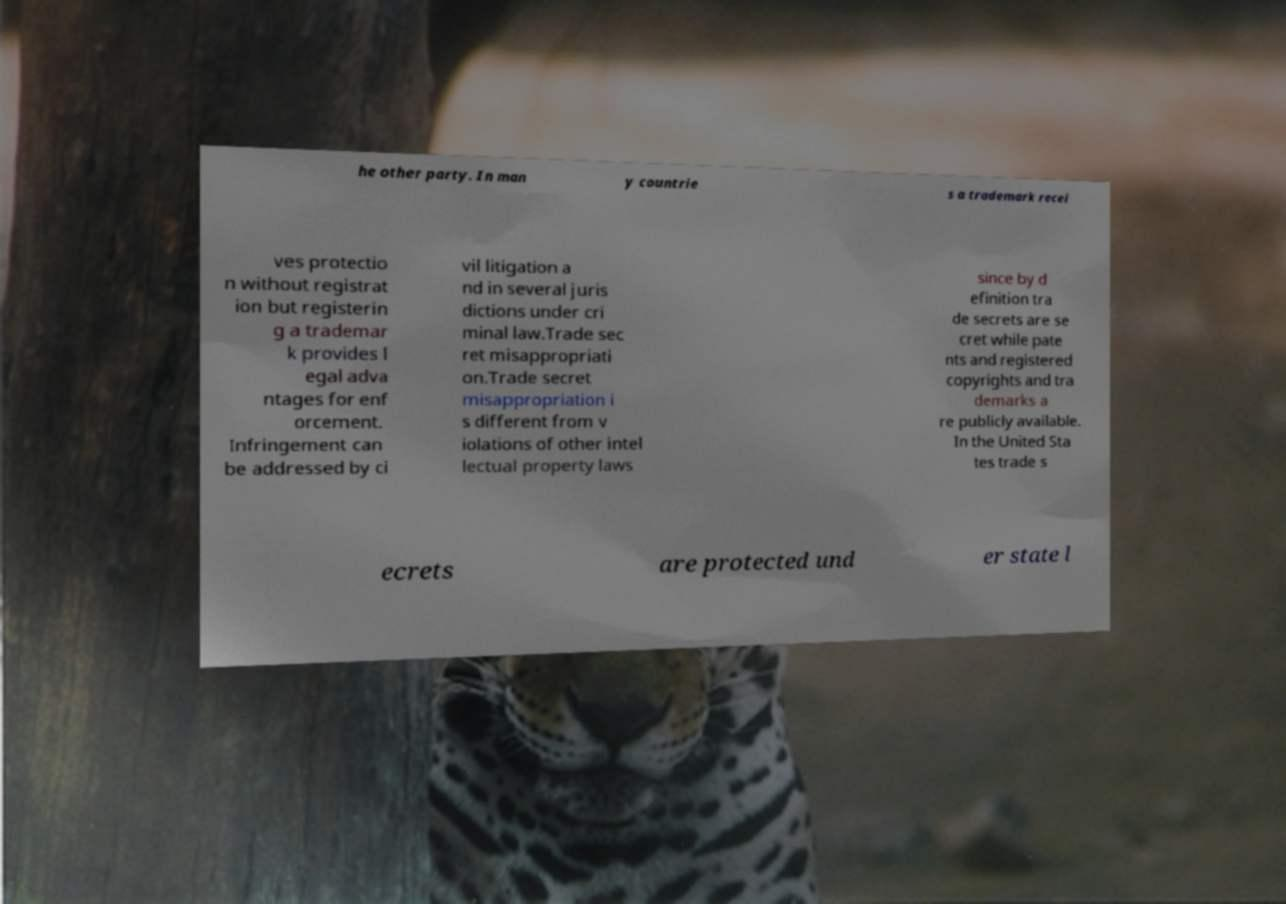For documentation purposes, I need the text within this image transcribed. Could you provide that? he other party. In man y countrie s a trademark recei ves protectio n without registrat ion but registerin g a trademar k provides l egal adva ntages for enf orcement. Infringement can be addressed by ci vil litigation a nd in several juris dictions under cri minal law.Trade sec ret misappropriati on.Trade secret misappropriation i s different from v iolations of other intel lectual property laws since by d efinition tra de secrets are se cret while pate nts and registered copyrights and tra demarks a re publicly available. In the United Sta tes trade s ecrets are protected und er state l 